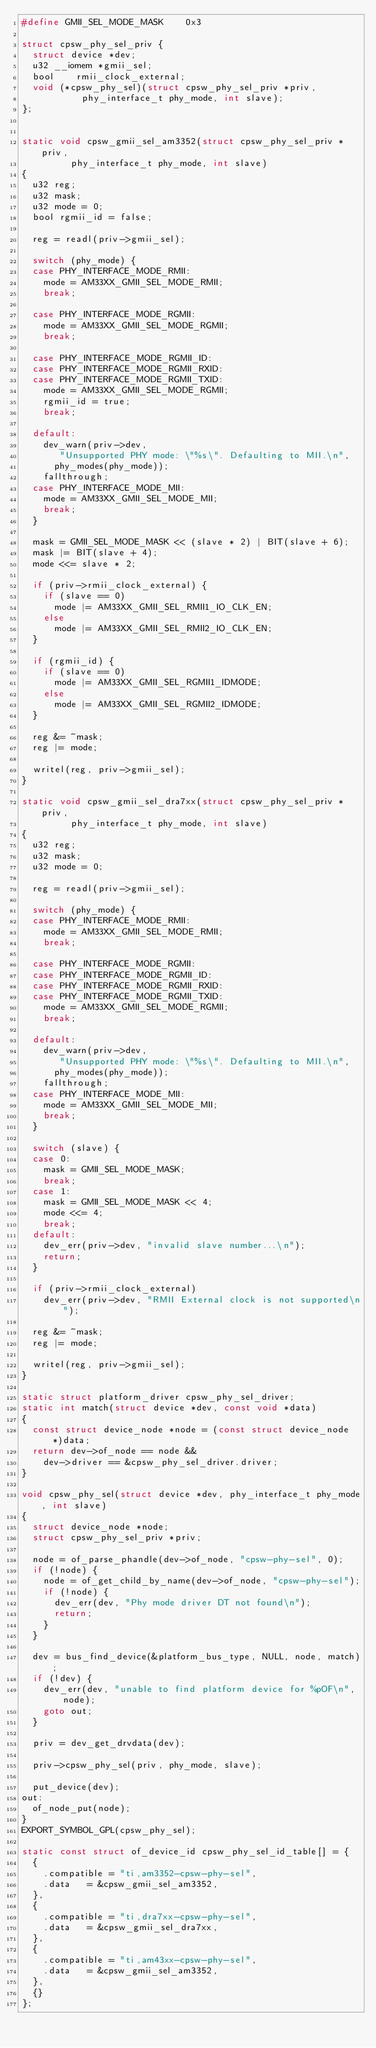<code> <loc_0><loc_0><loc_500><loc_500><_C_>#define GMII_SEL_MODE_MASK		0x3

struct cpsw_phy_sel_priv {
	struct device	*dev;
	u32 __iomem	*gmii_sel;
	bool		rmii_clock_external;
	void (*cpsw_phy_sel)(struct cpsw_phy_sel_priv *priv,
			     phy_interface_t phy_mode, int slave);
};


static void cpsw_gmii_sel_am3352(struct cpsw_phy_sel_priv *priv,
				 phy_interface_t phy_mode, int slave)
{
	u32 reg;
	u32 mask;
	u32 mode = 0;
	bool rgmii_id = false;

	reg = readl(priv->gmii_sel);

	switch (phy_mode) {
	case PHY_INTERFACE_MODE_RMII:
		mode = AM33XX_GMII_SEL_MODE_RMII;
		break;

	case PHY_INTERFACE_MODE_RGMII:
		mode = AM33XX_GMII_SEL_MODE_RGMII;
		break;

	case PHY_INTERFACE_MODE_RGMII_ID:
	case PHY_INTERFACE_MODE_RGMII_RXID:
	case PHY_INTERFACE_MODE_RGMII_TXID:
		mode = AM33XX_GMII_SEL_MODE_RGMII;
		rgmii_id = true;
		break;

	default:
		dev_warn(priv->dev,
			 "Unsupported PHY mode: \"%s\". Defaulting to MII.\n",
			phy_modes(phy_mode));
		fallthrough;
	case PHY_INTERFACE_MODE_MII:
		mode = AM33XX_GMII_SEL_MODE_MII;
		break;
	}

	mask = GMII_SEL_MODE_MASK << (slave * 2) | BIT(slave + 6);
	mask |= BIT(slave + 4);
	mode <<= slave * 2;

	if (priv->rmii_clock_external) {
		if (slave == 0)
			mode |= AM33XX_GMII_SEL_RMII1_IO_CLK_EN;
		else
			mode |= AM33XX_GMII_SEL_RMII2_IO_CLK_EN;
	}

	if (rgmii_id) {
		if (slave == 0)
			mode |= AM33XX_GMII_SEL_RGMII1_IDMODE;
		else
			mode |= AM33XX_GMII_SEL_RGMII2_IDMODE;
	}

	reg &= ~mask;
	reg |= mode;

	writel(reg, priv->gmii_sel);
}

static void cpsw_gmii_sel_dra7xx(struct cpsw_phy_sel_priv *priv,
				 phy_interface_t phy_mode, int slave)
{
	u32 reg;
	u32 mask;
	u32 mode = 0;

	reg = readl(priv->gmii_sel);

	switch (phy_mode) {
	case PHY_INTERFACE_MODE_RMII:
		mode = AM33XX_GMII_SEL_MODE_RMII;
		break;

	case PHY_INTERFACE_MODE_RGMII:
	case PHY_INTERFACE_MODE_RGMII_ID:
	case PHY_INTERFACE_MODE_RGMII_RXID:
	case PHY_INTERFACE_MODE_RGMII_TXID:
		mode = AM33XX_GMII_SEL_MODE_RGMII;
		break;

	default:
		dev_warn(priv->dev,
			 "Unsupported PHY mode: \"%s\". Defaulting to MII.\n",
			phy_modes(phy_mode));
		fallthrough;
	case PHY_INTERFACE_MODE_MII:
		mode = AM33XX_GMII_SEL_MODE_MII;
		break;
	}

	switch (slave) {
	case 0:
		mask = GMII_SEL_MODE_MASK;
		break;
	case 1:
		mask = GMII_SEL_MODE_MASK << 4;
		mode <<= 4;
		break;
	default:
		dev_err(priv->dev, "invalid slave number...\n");
		return;
	}

	if (priv->rmii_clock_external)
		dev_err(priv->dev, "RMII External clock is not supported\n");

	reg &= ~mask;
	reg |= mode;

	writel(reg, priv->gmii_sel);
}

static struct platform_driver cpsw_phy_sel_driver;
static int match(struct device *dev, const void *data)
{
	const struct device_node *node = (const struct device_node *)data;
	return dev->of_node == node &&
		dev->driver == &cpsw_phy_sel_driver.driver;
}

void cpsw_phy_sel(struct device *dev, phy_interface_t phy_mode, int slave)
{
	struct device_node *node;
	struct cpsw_phy_sel_priv *priv;

	node = of_parse_phandle(dev->of_node, "cpsw-phy-sel", 0);
	if (!node) {
		node = of_get_child_by_name(dev->of_node, "cpsw-phy-sel");
		if (!node) {
			dev_err(dev, "Phy mode driver DT not found\n");
			return;
		}
	}

	dev = bus_find_device(&platform_bus_type, NULL, node, match);
	if (!dev) {
		dev_err(dev, "unable to find platform device for %pOF\n", node);
		goto out;
	}

	priv = dev_get_drvdata(dev);

	priv->cpsw_phy_sel(priv, phy_mode, slave);

	put_device(dev);
out:
	of_node_put(node);
}
EXPORT_SYMBOL_GPL(cpsw_phy_sel);

static const struct of_device_id cpsw_phy_sel_id_table[] = {
	{
		.compatible	= "ti,am3352-cpsw-phy-sel",
		.data		= &cpsw_gmii_sel_am3352,
	},
	{
		.compatible	= "ti,dra7xx-cpsw-phy-sel",
		.data		= &cpsw_gmii_sel_dra7xx,
	},
	{
		.compatible	= "ti,am43xx-cpsw-phy-sel",
		.data		= &cpsw_gmii_sel_am3352,
	},
	{}
};
</code> 